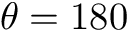<formula> <loc_0><loc_0><loc_500><loc_500>\theta = 1 8 0</formula> 